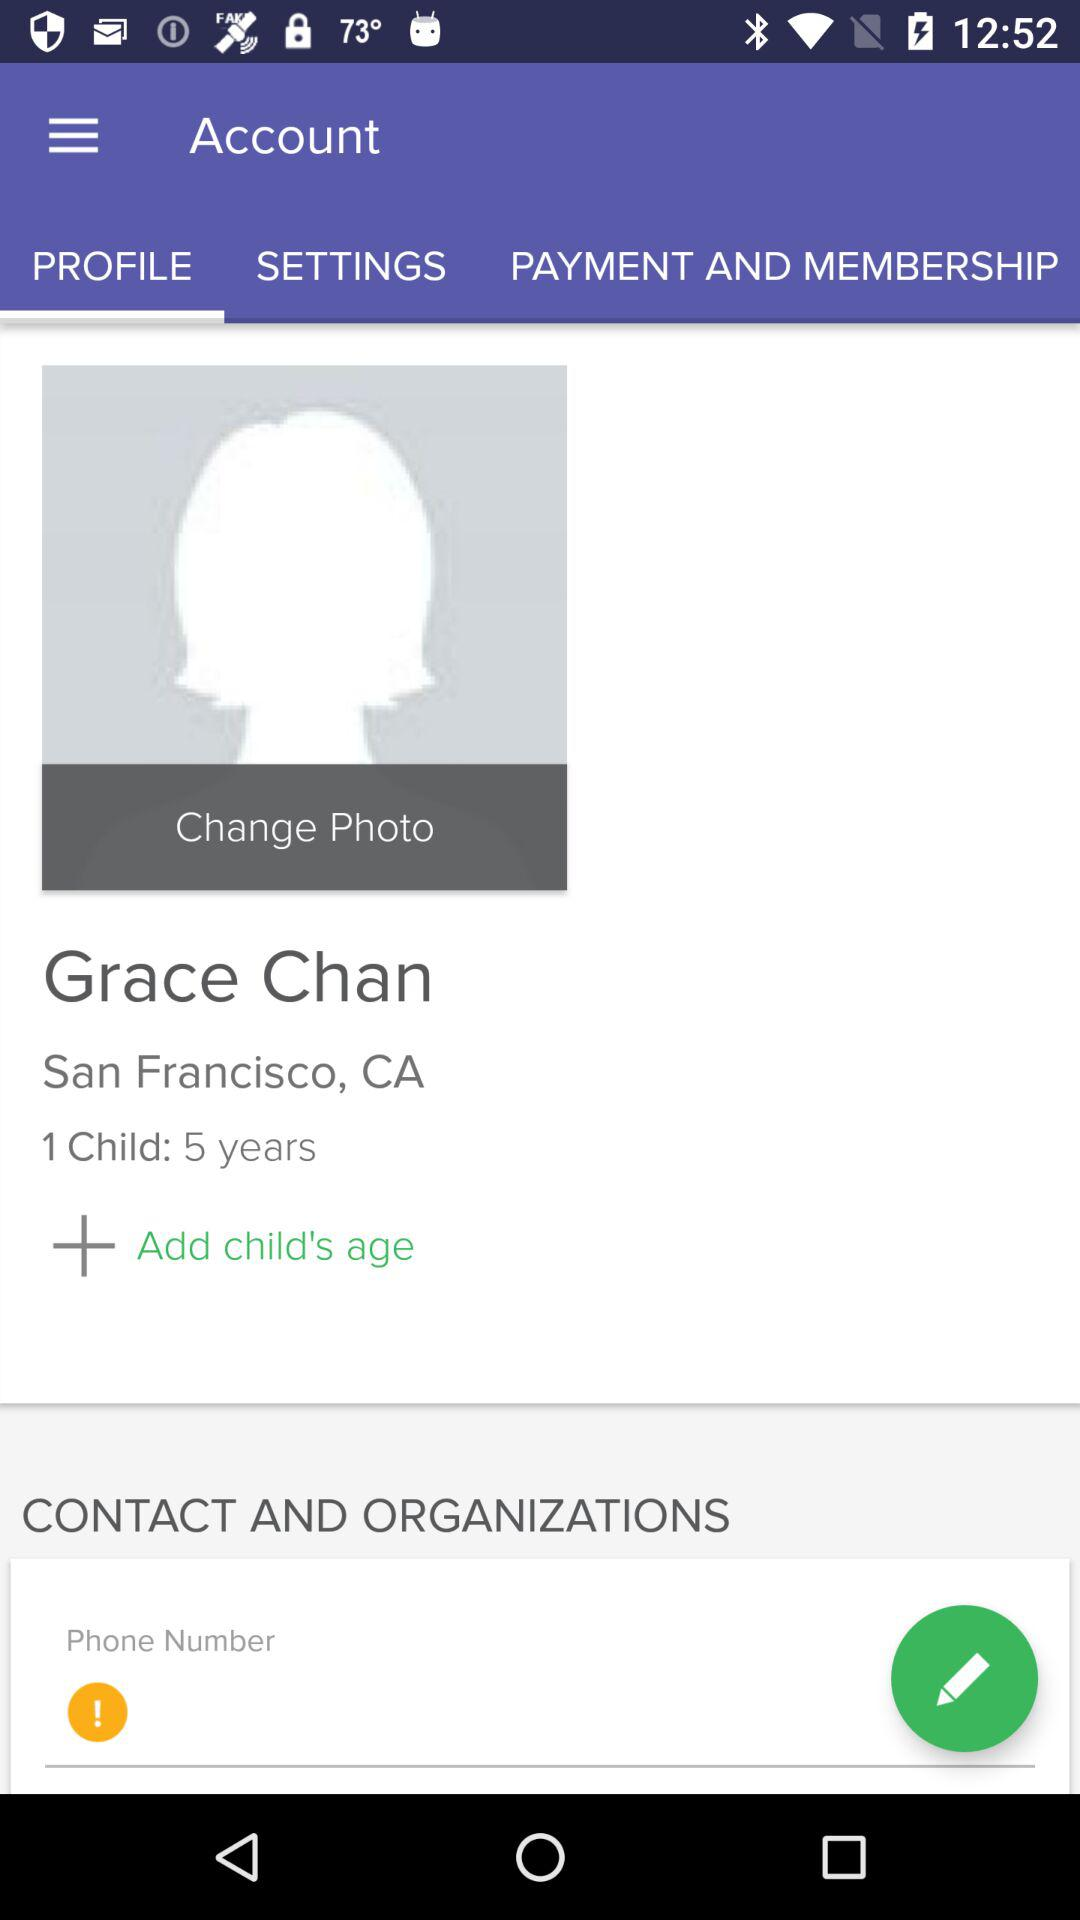How many children does the user have?
Answer the question using a single word or phrase. 1 